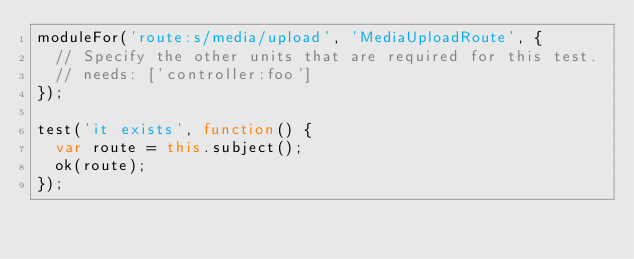Convert code to text. <code><loc_0><loc_0><loc_500><loc_500><_JavaScript_>moduleFor('route:s/media/upload', 'MediaUploadRoute', {
  // Specify the other units that are required for this test.
  // needs: ['controller:foo']
});

test('it exists', function() {
  var route = this.subject();
  ok(route);
});
</code> 